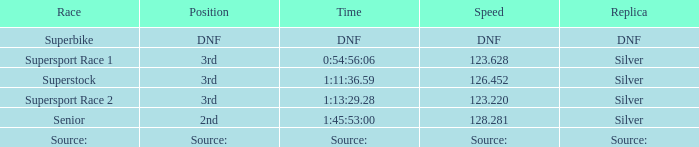Which ethnicity has a duplicate of dnf? Superbike. 